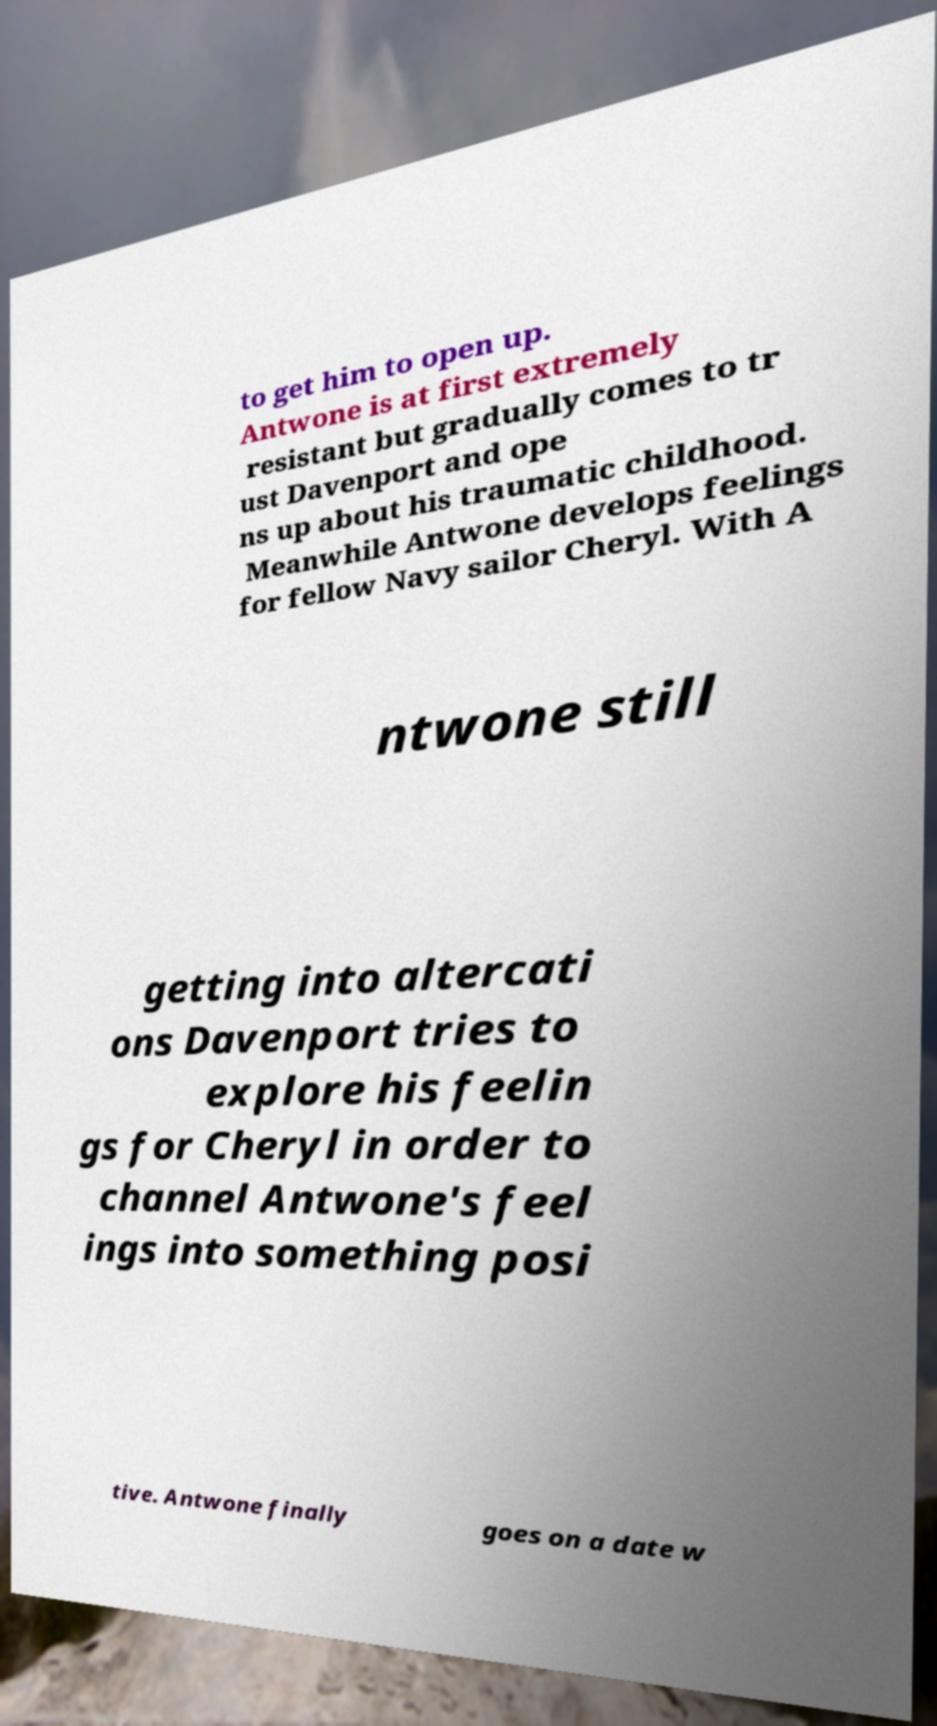What messages or text are displayed in this image? I need them in a readable, typed format. to get him to open up. Antwone is at first extremely resistant but gradually comes to tr ust Davenport and ope ns up about his traumatic childhood. Meanwhile Antwone develops feelings for fellow Navy sailor Cheryl. With A ntwone still getting into altercati ons Davenport tries to explore his feelin gs for Cheryl in order to channel Antwone's feel ings into something posi tive. Antwone finally goes on a date w 